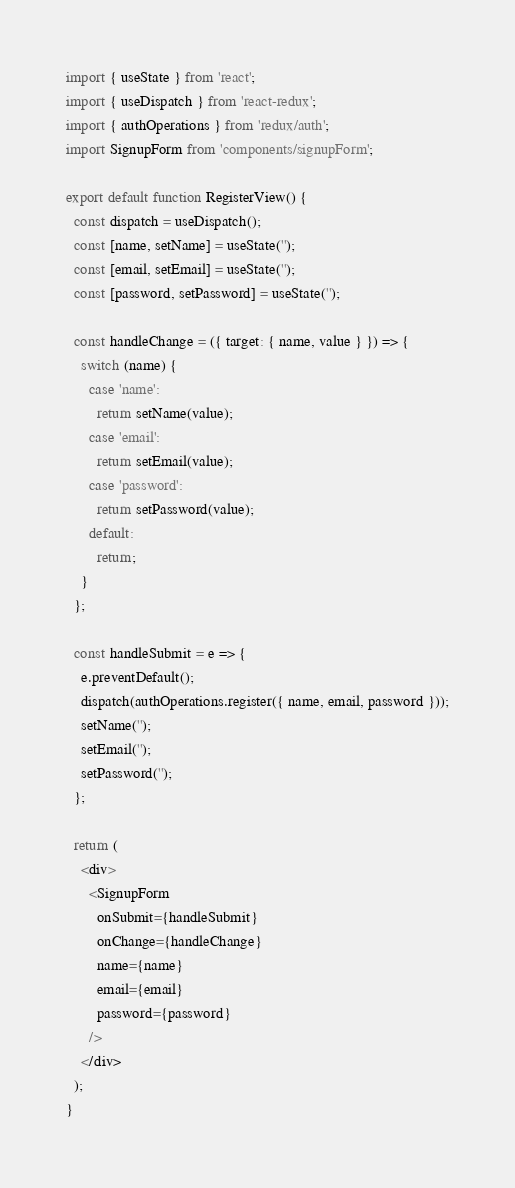Convert code to text. <code><loc_0><loc_0><loc_500><loc_500><_JavaScript_>import { useState } from 'react';
import { useDispatch } from 'react-redux';
import { authOperations } from 'redux/auth';
import SignupForm from 'components/signupForm';

export default function RegisterView() {
  const dispatch = useDispatch();
  const [name, setName] = useState('');
  const [email, setEmail] = useState('');
  const [password, setPassword] = useState('');

  const handleChange = ({ target: { name, value } }) => {
    switch (name) {
      case 'name':
        return setName(value);
      case 'email':
        return setEmail(value);
      case 'password':
        return setPassword(value);
      default:
        return;
    }
  };

  const handleSubmit = e => {
    e.preventDefault();
    dispatch(authOperations.register({ name, email, password }));
    setName('');
    setEmail('');
    setPassword('');
  };

  return (
    <div>
      <SignupForm
        onSubmit={handleSubmit}
        onChange={handleChange}
        name={name}
        email={email}
        password={password}
      />
    </div>
  );
}
</code> 